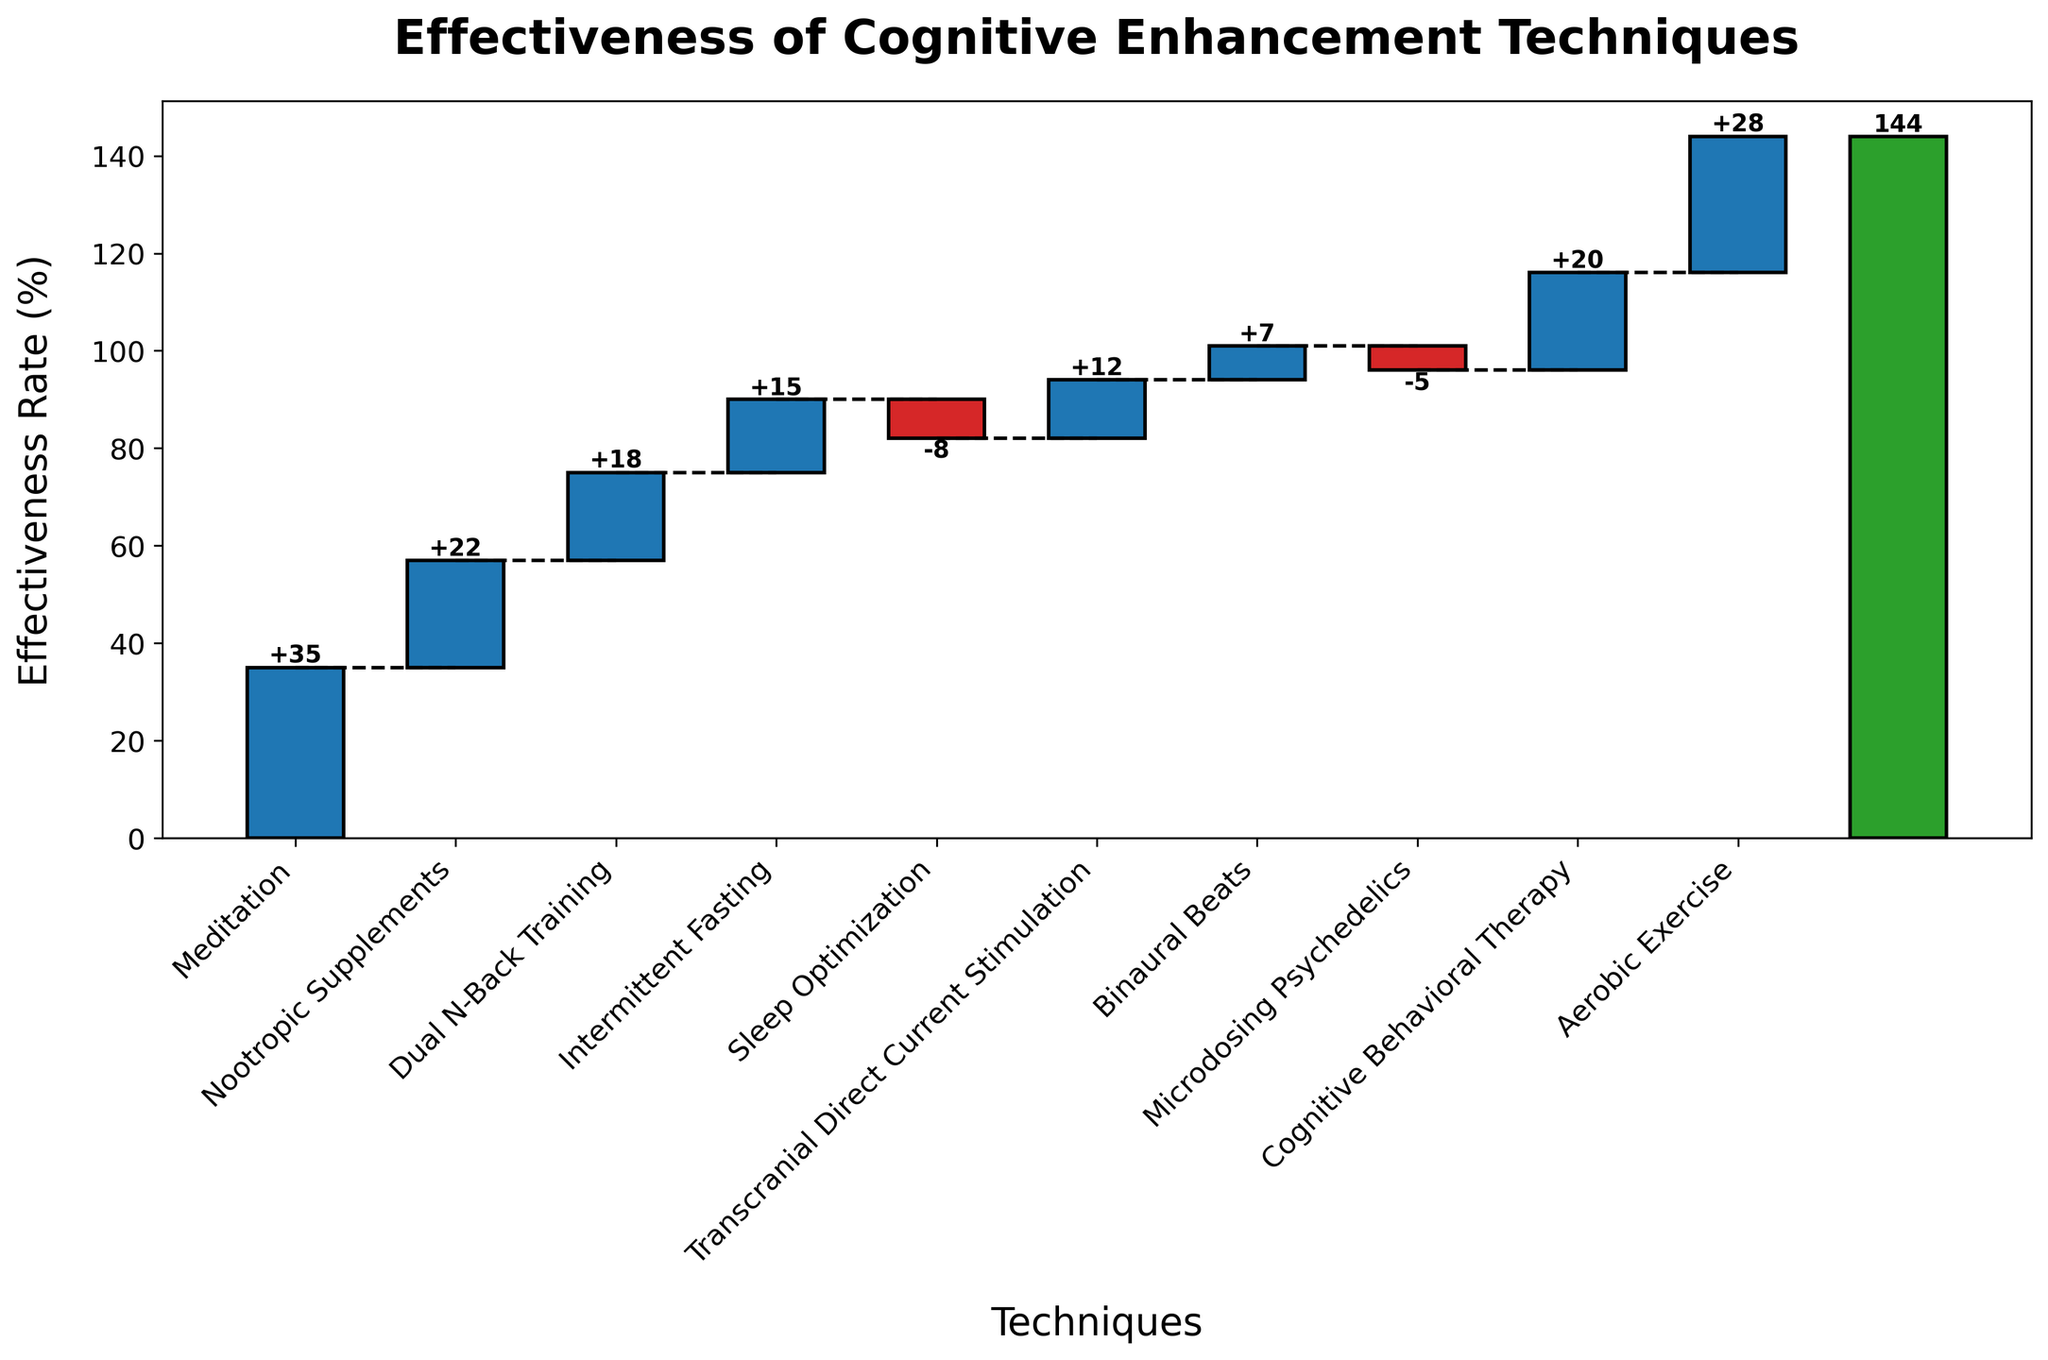What's the title of the chart? The title of the chart can be found at the top of the figure and states the main subject of the data being visualized.
Answer: Effectiveness of Cognitive Enhancement Techniques What is the effectiveness rate for Meditation? The effectiveness rates are listed along with each technique's bar in the chart. The effectiveness rate for Meditation is clearly labeled on its corresponding bar.
Answer: 35 How many techniques show a negative effectiveness rate? Count the bars that extend below the horizontal line at y=0, which indicates negative effectiveness rates.
Answer: 2 Which technique has the highest effectiveness rate? Identify the bar that extends the farthest above the horizontal line at y=0 and check its label.
Answer: Meditation What is the cumulative effectiveness rate after Sleep Optimization? The cumulative effectiveness rate is the sum of the effectiveness rates up to and including Sleep Optimization. This can be visually identified by the position of the cumulative line after Sleep Optimization.
Answer: 82 What is the combined effectiveness rate of the top three techniques? Sum the effectiveness rates of Meditation (35), Aerobic Exercise (28), and Nootropic Supplements (22).
Answer: 85 Which technique increased the total effectiveness rate the most apart from Meditation? Identify the bar with the highest positive value apart from Meditation by comparing the heights of the bars above the horizontal line at y=0.
Answer: Aerobic Exercise How much does Cognitive Behavioral Therapy contribute to the total effectiveness rate? Look at the height of the Cognitive Behavioral Therapy bar and note its labeled effectiveness rate.
Answer: 20 What is the difference in effectiveness rates between Nootropic Supplements and Microdosing Psychedelics? Subtract the effectiveness rate of Microdosing Psychedelics from that of Nootropic Supplements (22 - (-5)).
Answer: 27 After how many techniques does the cumulative effectiveness rate exceed 50? Observe the cumulative line and identify the number of techniques where the cumulative sum first surpasses 50. This occurs at the point after adding the effectiveness rates cumulatively.
Answer: After 2 techniques 